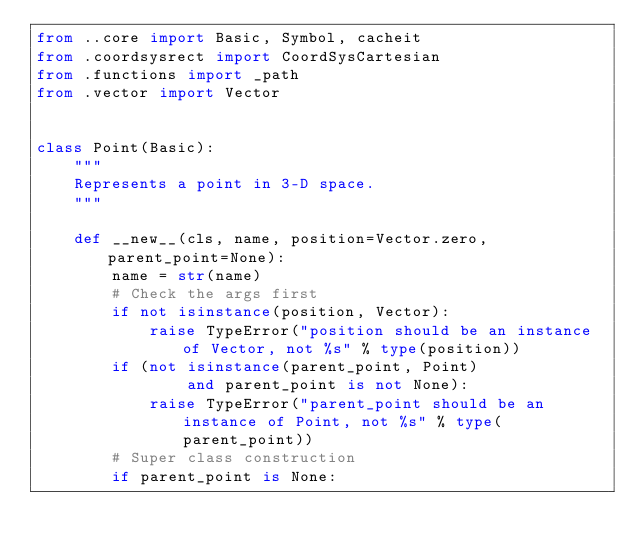Convert code to text. <code><loc_0><loc_0><loc_500><loc_500><_Python_>from ..core import Basic, Symbol, cacheit
from .coordsysrect import CoordSysCartesian
from .functions import _path
from .vector import Vector


class Point(Basic):
    """
    Represents a point in 3-D space.
    """

    def __new__(cls, name, position=Vector.zero, parent_point=None):
        name = str(name)
        # Check the args first
        if not isinstance(position, Vector):
            raise TypeError("position should be an instance of Vector, not %s" % type(position))
        if (not isinstance(parent_point, Point)
                and parent_point is not None):
            raise TypeError("parent_point should be an instance of Point, not %s" % type(parent_point))
        # Super class construction
        if parent_point is None:</code> 